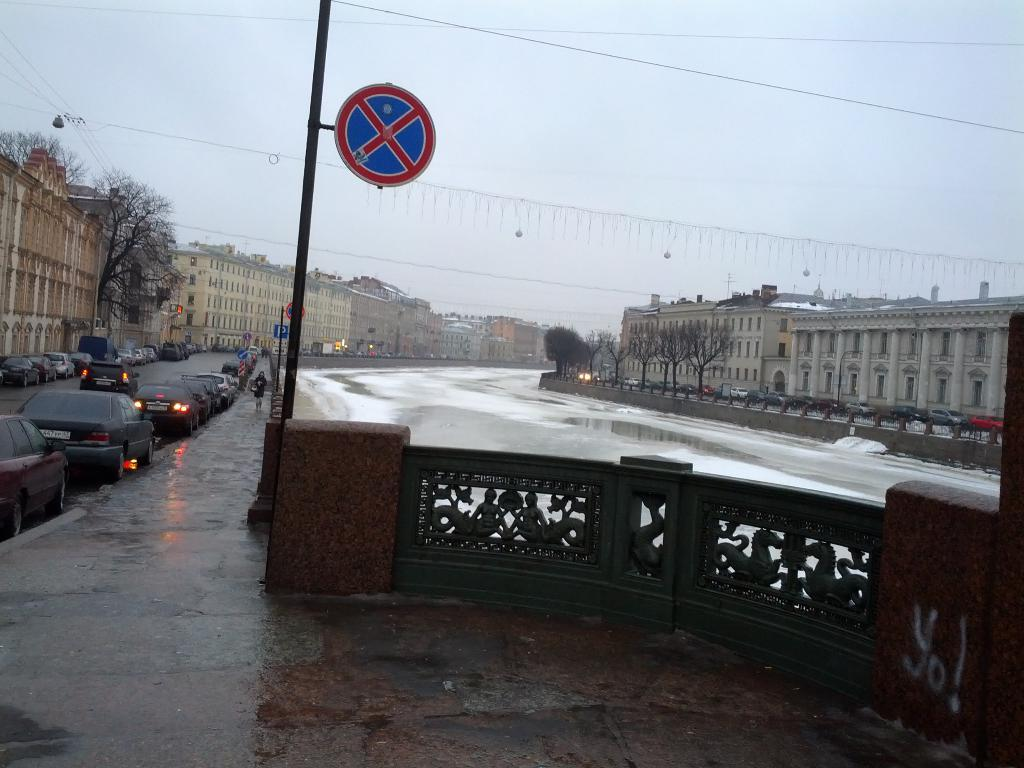What can be seen in the image related to transportation? There is a group of vehicles in the image. What else is happening on the road in the image? There are people on the road in the image. What type of barrier is present in the image? There is a fence in the image. What might provide information or directions in the image? Sign boards are present in the image. What type of vegetation is visible in the image? Trees are visible in the image. What type of structures are present in the image? Buildings are present in the image. What type of infrastructure is visible in the image? Wires are visible in the image. What type of natural element is visible in the image? There is water visible in the image. What can be seen in the background of the image? The sky is visible in the background of the image. How many toes are visible on the chicken in the image? There is no chicken present in the image. What type of adjustment is being made to the wires in the image? There is no adjustment being made to the wires in the image; they are simply visible. 